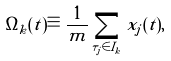Convert formula to latex. <formula><loc_0><loc_0><loc_500><loc_500>\Omega _ { k } ( t ) \equiv \frac { 1 } { m } \sum _ { \tau _ { j } \in I _ { k } } x _ { j } ( t ) ,</formula> 